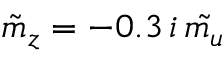<formula> <loc_0><loc_0><loc_500><loc_500>\tilde { m } _ { z } = - 0 . 3 \, i \, \tilde { m _ { u } }</formula> 